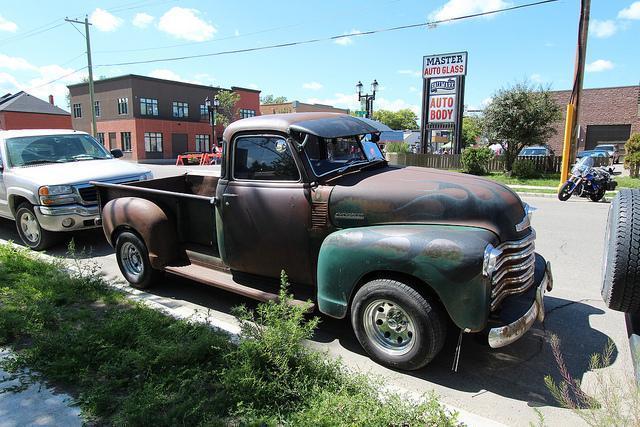What sort of business are the autos in all likelihood closest to?
From the following four choices, select the correct answer to address the question.
Options: Gas station, restaurant, auto repair, dealership. Auto repair. 